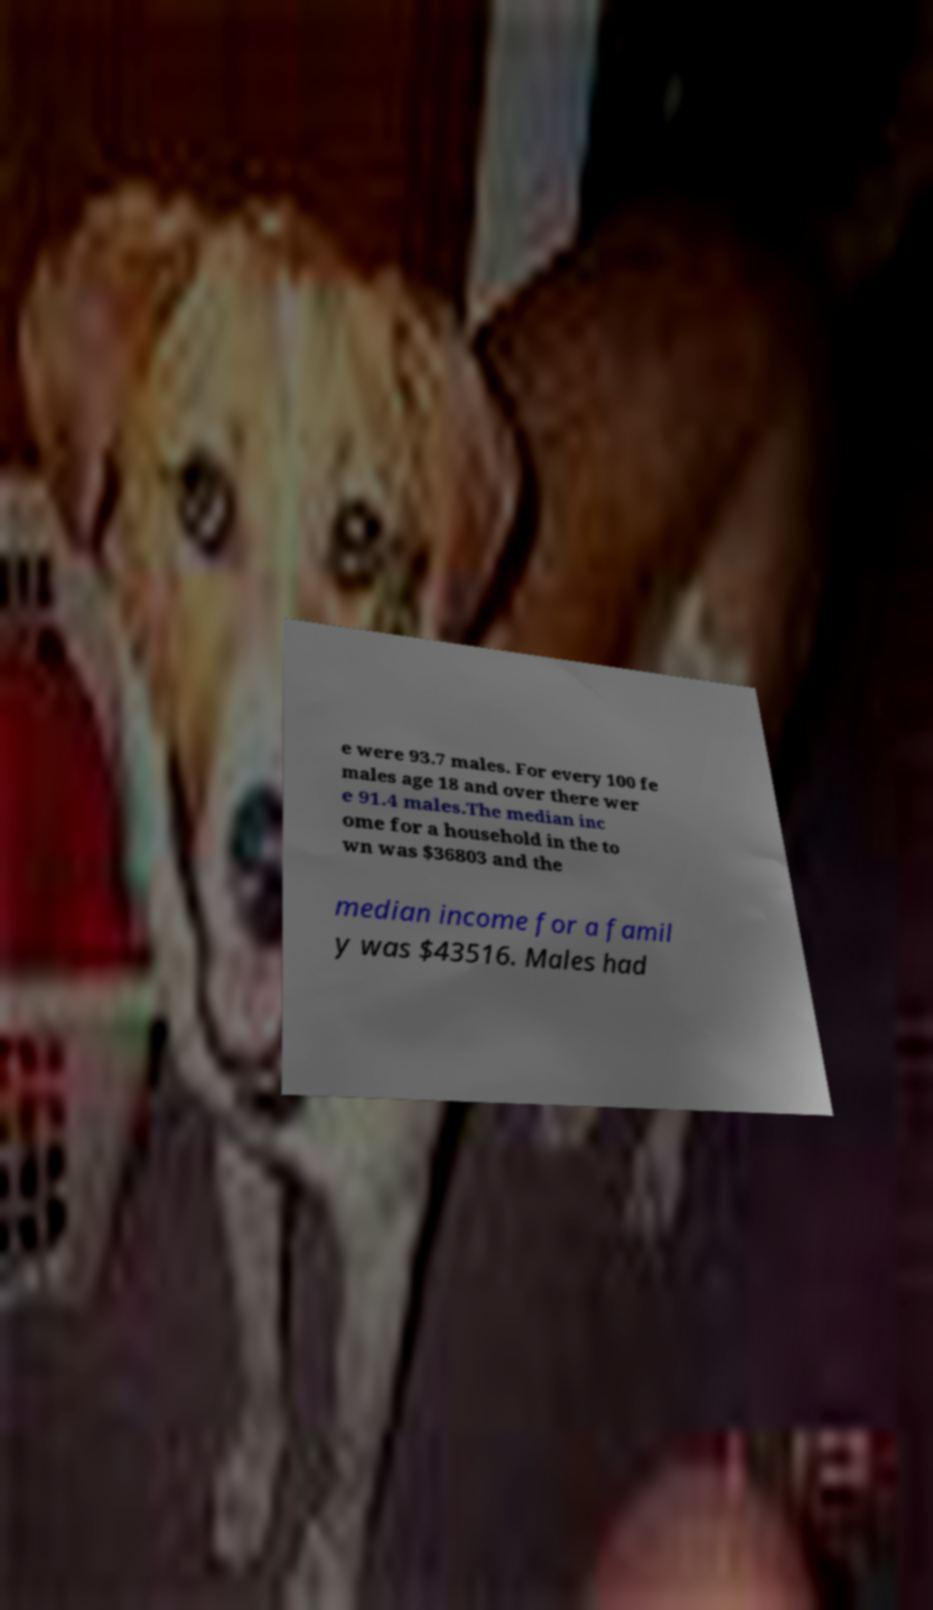What messages or text are displayed in this image? I need them in a readable, typed format. e were 93.7 males. For every 100 fe males age 18 and over there wer e 91.4 males.The median inc ome for a household in the to wn was $36803 and the median income for a famil y was $43516. Males had 